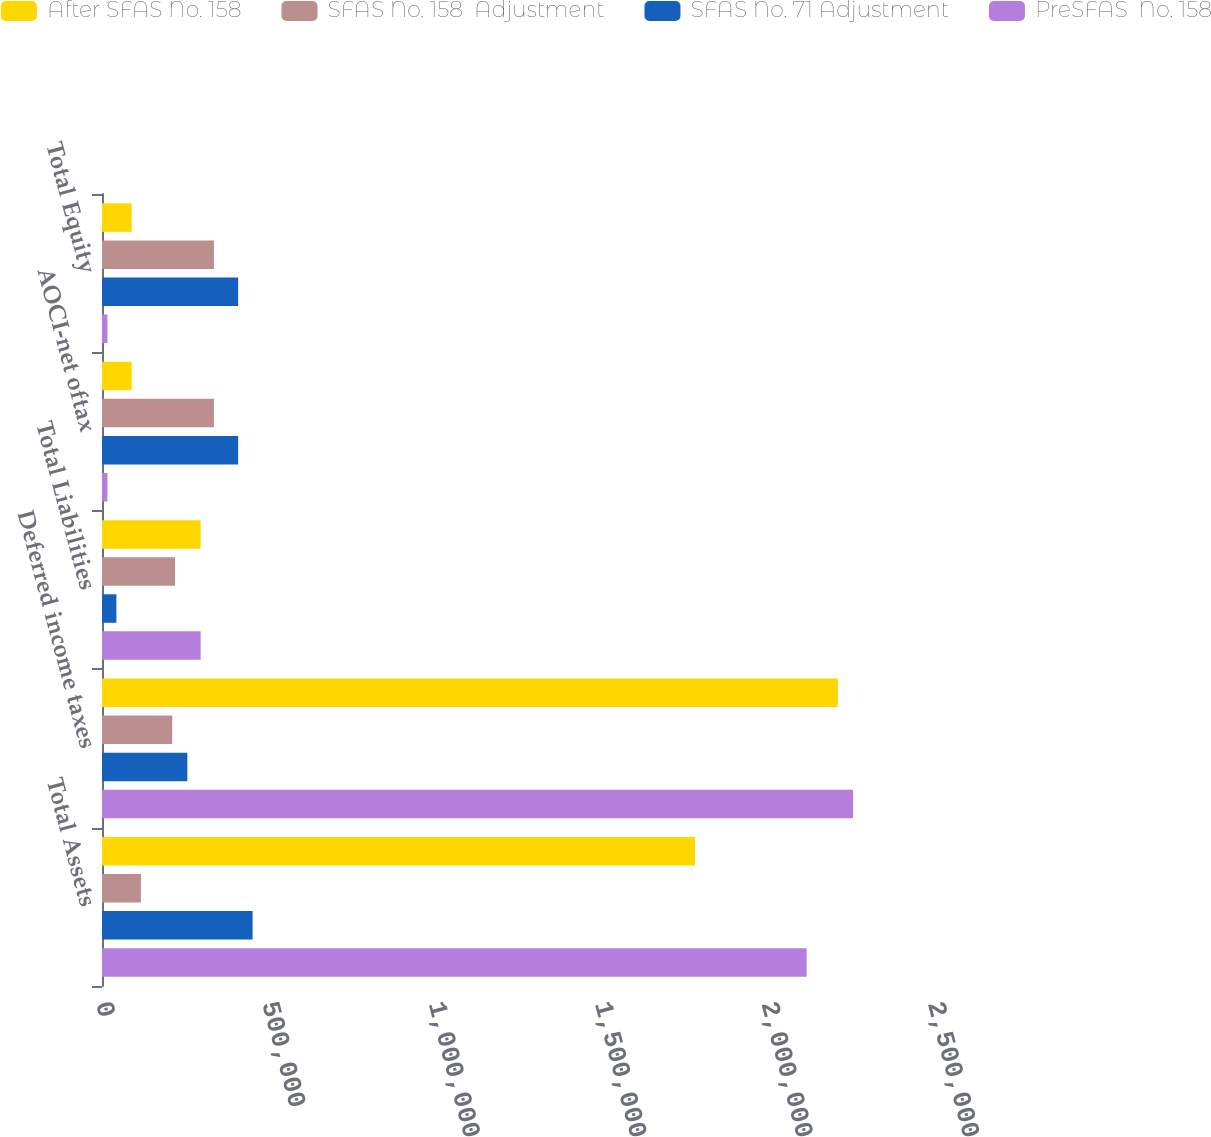<chart> <loc_0><loc_0><loc_500><loc_500><stacked_bar_chart><ecel><fcel>Total Assets<fcel>Deferred income taxes<fcel>Total Liabilities<fcel>AOCI-net oftax<fcel>Total Equity<nl><fcel>After SFAS No. 158<fcel>1.7819e+06<fcel>2.21125e+06<fcel>296382<fcel>89130<fcel>89130<nl><fcel>SFAS No. 158  Adjustment<fcel>117023<fcel>211061<fcel>219330<fcel>336353<fcel>336353<nl><fcel>SFAS No. 71 Adjustment<fcel>452472<fcel>256410<fcel>43315<fcel>409157<fcel>409157<nl><fcel>PreSFAS  No. 158<fcel>2.11735e+06<fcel>2.2566e+06<fcel>296382<fcel>16326<fcel>16326<nl></chart> 